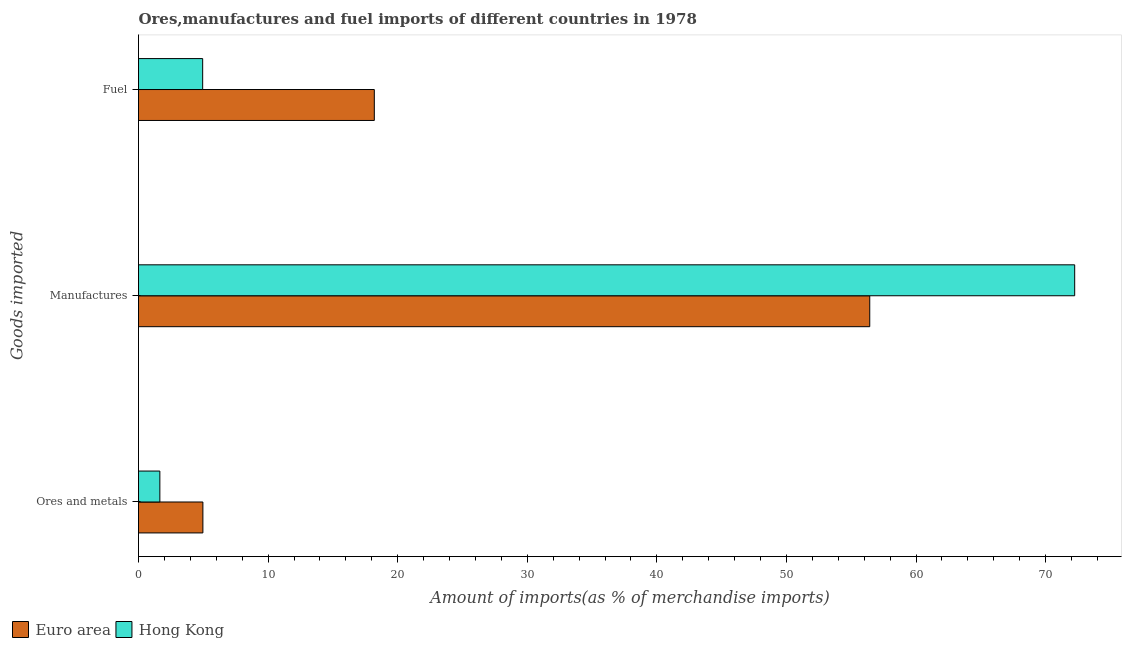How many groups of bars are there?
Make the answer very short. 3. How many bars are there on the 3rd tick from the bottom?
Ensure brevity in your answer.  2. What is the label of the 1st group of bars from the top?
Your response must be concise. Fuel. What is the percentage of manufactures imports in Euro area?
Provide a short and direct response. 56.43. Across all countries, what is the maximum percentage of manufactures imports?
Make the answer very short. 72.24. Across all countries, what is the minimum percentage of ores and metals imports?
Make the answer very short. 1.65. In which country was the percentage of ores and metals imports maximum?
Ensure brevity in your answer.  Euro area. In which country was the percentage of ores and metals imports minimum?
Your answer should be compact. Hong Kong. What is the total percentage of manufactures imports in the graph?
Ensure brevity in your answer.  128.67. What is the difference between the percentage of ores and metals imports in Hong Kong and that in Euro area?
Provide a succinct answer. -3.32. What is the difference between the percentage of fuel imports in Hong Kong and the percentage of ores and metals imports in Euro area?
Offer a very short reply. -0.02. What is the average percentage of ores and metals imports per country?
Keep it short and to the point. 3.31. What is the difference between the percentage of ores and metals imports and percentage of manufactures imports in Euro area?
Provide a succinct answer. -51.46. In how many countries, is the percentage of manufactures imports greater than 10 %?
Your response must be concise. 2. What is the ratio of the percentage of fuel imports in Hong Kong to that in Euro area?
Provide a succinct answer. 0.27. Is the difference between the percentage of manufactures imports in Hong Kong and Euro area greater than the difference between the percentage of ores and metals imports in Hong Kong and Euro area?
Provide a succinct answer. Yes. What is the difference between the highest and the second highest percentage of ores and metals imports?
Your response must be concise. 3.32. What is the difference between the highest and the lowest percentage of ores and metals imports?
Your answer should be very brief. 3.32. In how many countries, is the percentage of fuel imports greater than the average percentage of fuel imports taken over all countries?
Offer a terse response. 1. Is the sum of the percentage of ores and metals imports in Hong Kong and Euro area greater than the maximum percentage of manufactures imports across all countries?
Keep it short and to the point. No. What does the 2nd bar from the bottom in Manufactures represents?
Provide a succinct answer. Hong Kong. Is it the case that in every country, the sum of the percentage of ores and metals imports and percentage of manufactures imports is greater than the percentage of fuel imports?
Ensure brevity in your answer.  Yes. Are all the bars in the graph horizontal?
Ensure brevity in your answer.  Yes. Does the graph contain any zero values?
Provide a short and direct response. No. Where does the legend appear in the graph?
Offer a terse response. Bottom left. How many legend labels are there?
Make the answer very short. 2. What is the title of the graph?
Give a very brief answer. Ores,manufactures and fuel imports of different countries in 1978. What is the label or title of the X-axis?
Provide a short and direct response. Amount of imports(as % of merchandise imports). What is the label or title of the Y-axis?
Your answer should be compact. Goods imported. What is the Amount of imports(as % of merchandise imports) of Euro area in Ores and metals?
Make the answer very short. 4.97. What is the Amount of imports(as % of merchandise imports) in Hong Kong in Ores and metals?
Give a very brief answer. 1.65. What is the Amount of imports(as % of merchandise imports) in Euro area in Manufactures?
Offer a terse response. 56.43. What is the Amount of imports(as % of merchandise imports) of Hong Kong in Manufactures?
Offer a very short reply. 72.24. What is the Amount of imports(as % of merchandise imports) of Euro area in Fuel?
Make the answer very short. 18.2. What is the Amount of imports(as % of merchandise imports) of Hong Kong in Fuel?
Ensure brevity in your answer.  4.95. Across all Goods imported, what is the maximum Amount of imports(as % of merchandise imports) of Euro area?
Ensure brevity in your answer.  56.43. Across all Goods imported, what is the maximum Amount of imports(as % of merchandise imports) of Hong Kong?
Give a very brief answer. 72.24. Across all Goods imported, what is the minimum Amount of imports(as % of merchandise imports) in Euro area?
Give a very brief answer. 4.97. Across all Goods imported, what is the minimum Amount of imports(as % of merchandise imports) in Hong Kong?
Give a very brief answer. 1.65. What is the total Amount of imports(as % of merchandise imports) of Euro area in the graph?
Offer a terse response. 79.59. What is the total Amount of imports(as % of merchandise imports) of Hong Kong in the graph?
Keep it short and to the point. 78.84. What is the difference between the Amount of imports(as % of merchandise imports) in Euro area in Ores and metals and that in Manufactures?
Make the answer very short. -51.46. What is the difference between the Amount of imports(as % of merchandise imports) of Hong Kong in Ores and metals and that in Manufactures?
Give a very brief answer. -70.59. What is the difference between the Amount of imports(as % of merchandise imports) in Euro area in Ores and metals and that in Fuel?
Keep it short and to the point. -13.23. What is the difference between the Amount of imports(as % of merchandise imports) in Hong Kong in Ores and metals and that in Fuel?
Ensure brevity in your answer.  -3.3. What is the difference between the Amount of imports(as % of merchandise imports) in Euro area in Manufactures and that in Fuel?
Offer a terse response. 38.23. What is the difference between the Amount of imports(as % of merchandise imports) in Hong Kong in Manufactures and that in Fuel?
Offer a very short reply. 67.29. What is the difference between the Amount of imports(as % of merchandise imports) of Euro area in Ores and metals and the Amount of imports(as % of merchandise imports) of Hong Kong in Manufactures?
Keep it short and to the point. -67.27. What is the difference between the Amount of imports(as % of merchandise imports) of Euro area in Ores and metals and the Amount of imports(as % of merchandise imports) of Hong Kong in Fuel?
Your answer should be compact. 0.02. What is the difference between the Amount of imports(as % of merchandise imports) in Euro area in Manufactures and the Amount of imports(as % of merchandise imports) in Hong Kong in Fuel?
Provide a short and direct response. 51.47. What is the average Amount of imports(as % of merchandise imports) in Euro area per Goods imported?
Provide a succinct answer. 26.53. What is the average Amount of imports(as % of merchandise imports) in Hong Kong per Goods imported?
Offer a terse response. 26.28. What is the difference between the Amount of imports(as % of merchandise imports) of Euro area and Amount of imports(as % of merchandise imports) of Hong Kong in Ores and metals?
Offer a terse response. 3.32. What is the difference between the Amount of imports(as % of merchandise imports) in Euro area and Amount of imports(as % of merchandise imports) in Hong Kong in Manufactures?
Offer a terse response. -15.81. What is the difference between the Amount of imports(as % of merchandise imports) in Euro area and Amount of imports(as % of merchandise imports) in Hong Kong in Fuel?
Your answer should be compact. 13.24. What is the ratio of the Amount of imports(as % of merchandise imports) of Euro area in Ores and metals to that in Manufactures?
Keep it short and to the point. 0.09. What is the ratio of the Amount of imports(as % of merchandise imports) of Hong Kong in Ores and metals to that in Manufactures?
Make the answer very short. 0.02. What is the ratio of the Amount of imports(as % of merchandise imports) of Euro area in Ores and metals to that in Fuel?
Ensure brevity in your answer.  0.27. What is the ratio of the Amount of imports(as % of merchandise imports) in Hong Kong in Ores and metals to that in Fuel?
Make the answer very short. 0.33. What is the ratio of the Amount of imports(as % of merchandise imports) in Euro area in Manufactures to that in Fuel?
Your answer should be very brief. 3.1. What is the ratio of the Amount of imports(as % of merchandise imports) in Hong Kong in Manufactures to that in Fuel?
Provide a short and direct response. 14.59. What is the difference between the highest and the second highest Amount of imports(as % of merchandise imports) in Euro area?
Your answer should be very brief. 38.23. What is the difference between the highest and the second highest Amount of imports(as % of merchandise imports) in Hong Kong?
Give a very brief answer. 67.29. What is the difference between the highest and the lowest Amount of imports(as % of merchandise imports) of Euro area?
Offer a terse response. 51.46. What is the difference between the highest and the lowest Amount of imports(as % of merchandise imports) in Hong Kong?
Offer a very short reply. 70.59. 